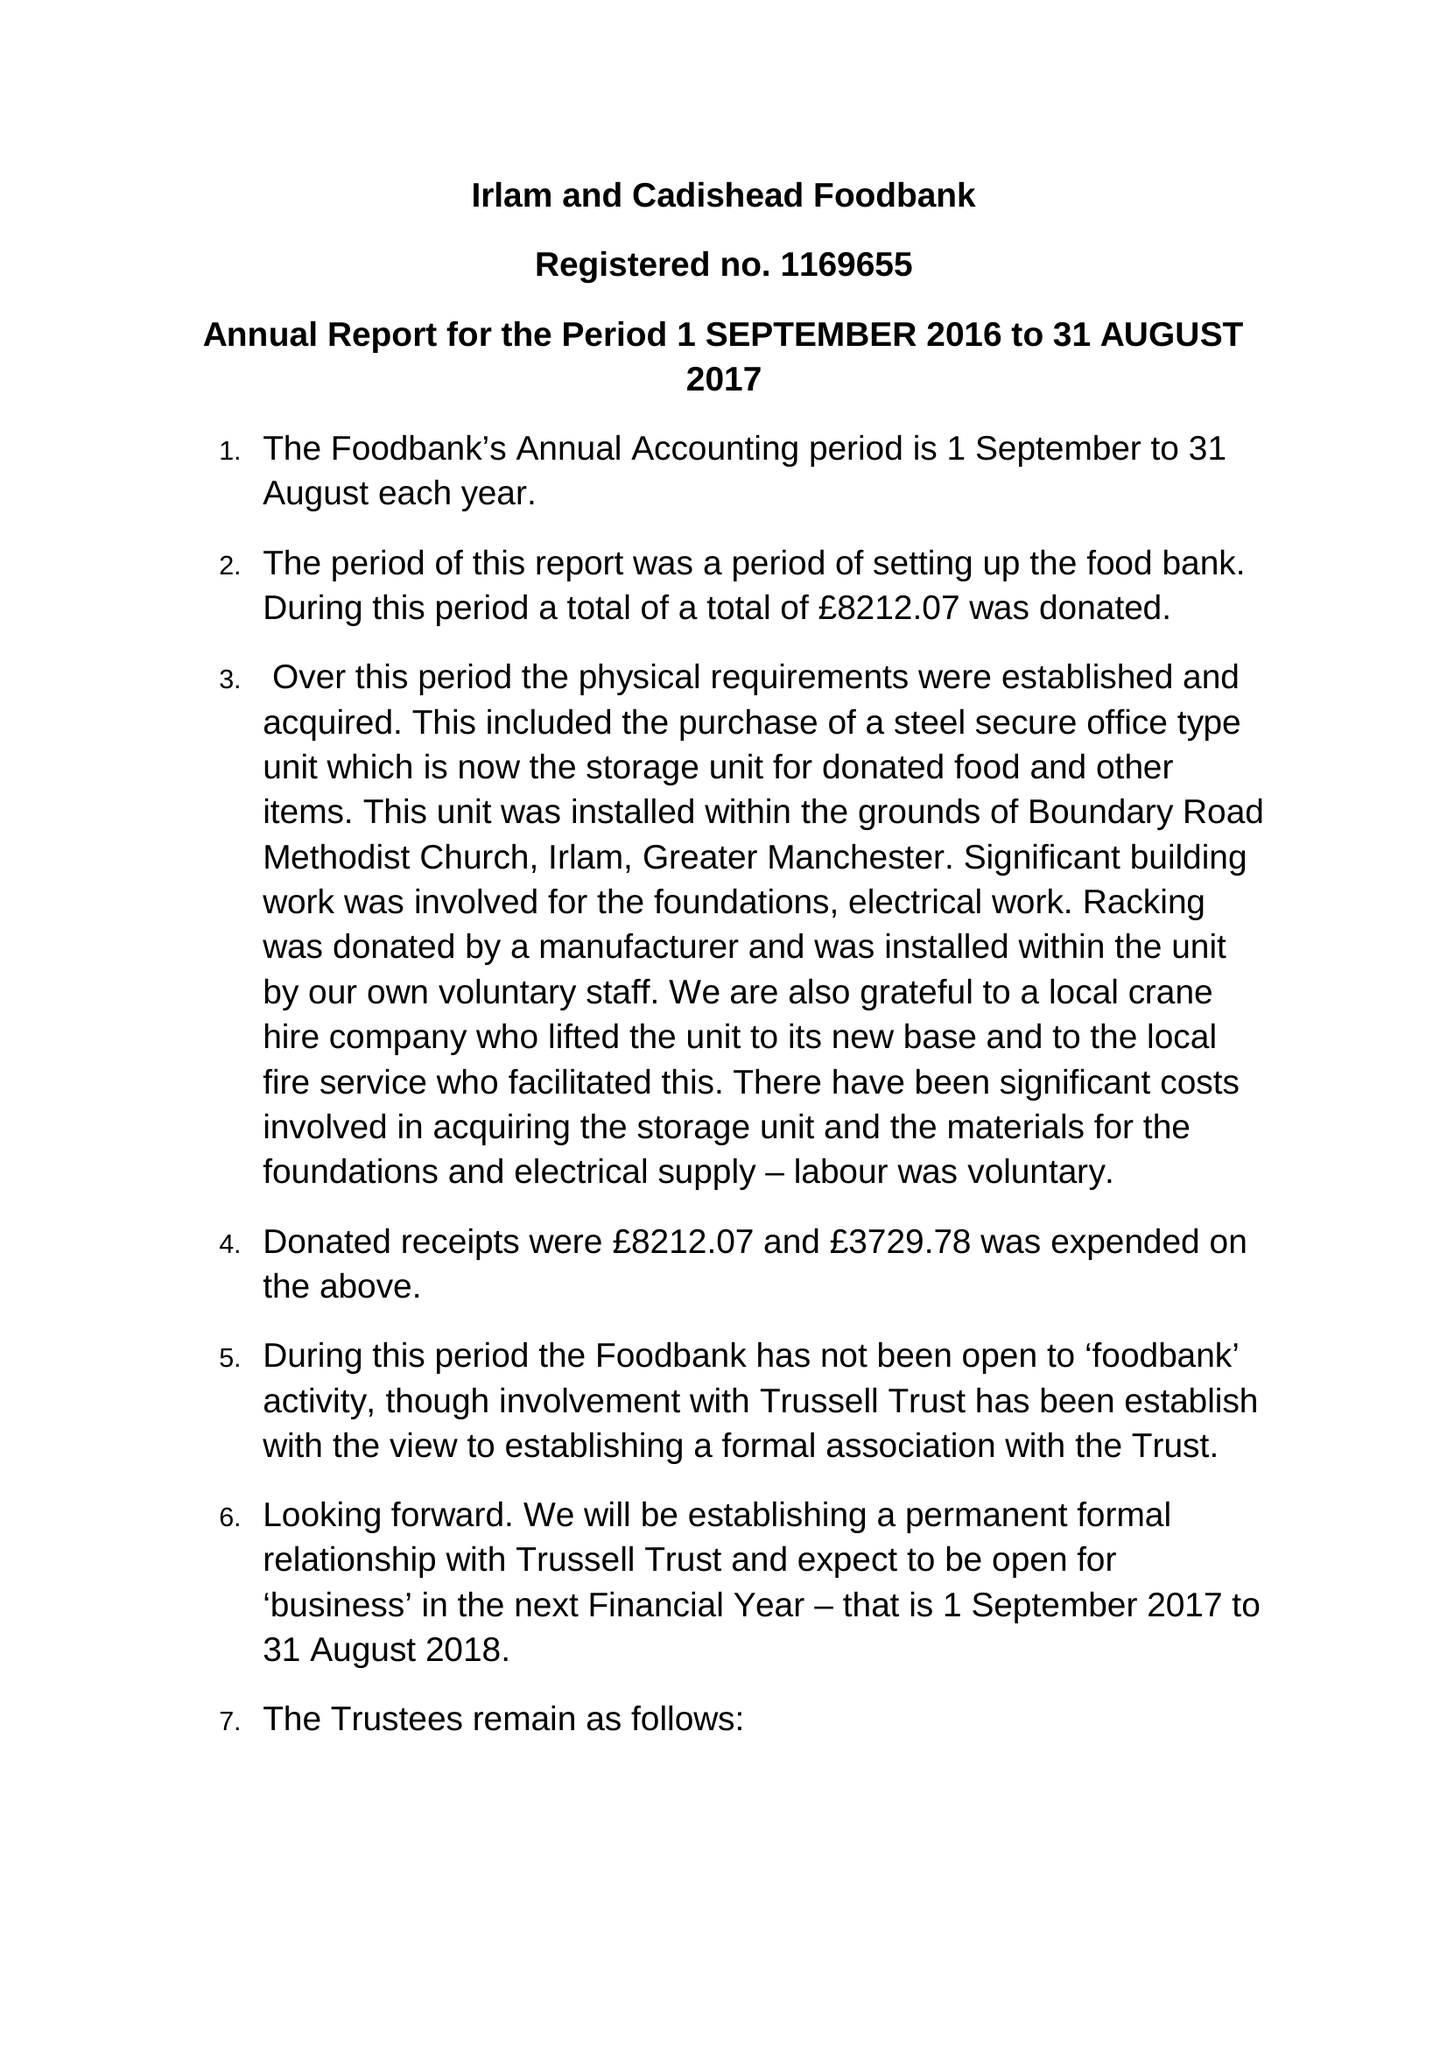What is the value for the charity_name?
Answer the question using a single word or phrase. Irlam and Cadishead Foodbank 